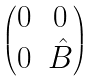Convert formula to latex. <formula><loc_0><loc_0><loc_500><loc_500>\begin{pmatrix} 0 & 0 \\ 0 & \hat { B } \end{pmatrix}</formula> 